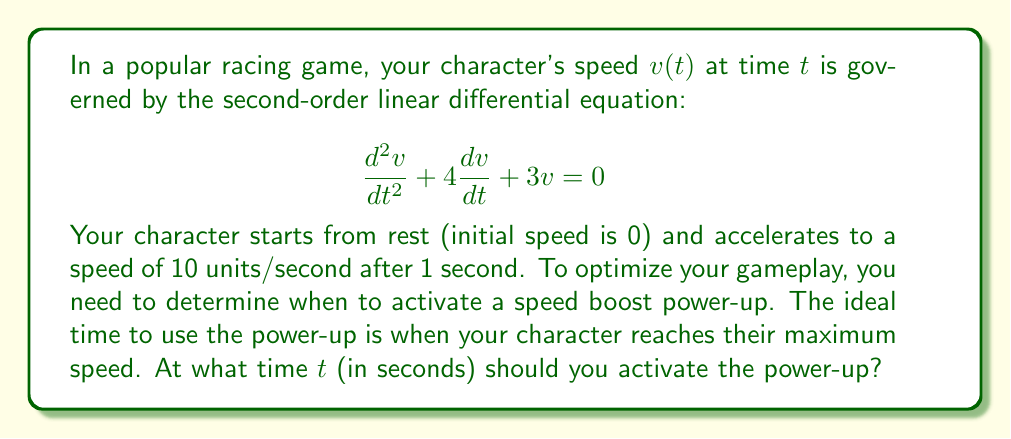Help me with this question. Let's approach this step-by-step:

1) First, we need to solve the differential equation. The characteristic equation is:
   
   $$r^2 + 4r + 3 = 0$$

2) Solving this quadratic equation:
   
   $$r = \frac{-4 \pm \sqrt{16 - 12}}{2} = \frac{-4 \pm 2}{2}$$
   
   $$r_1 = -1, r_2 = -3$$

3) Therefore, the general solution is:
   
   $$v(t) = c_1e^{-t} + c_2e^{-3t}$$

4) Now, we use the initial conditions:
   
   At $t=0$, $v(0) = 0$: $c_1 + c_2 = 0$
   At $t=1$, $v(1) = 10$: $c_1e^{-1} + c_2e^{-3} = 10$

5) From the first condition: $c_2 = -c_1$
   Substituting into the second condition:
   
   $$c_1e^{-1} - c_1e^{-3} = 10$$
   $$c_1(e^{-1} - e^{-3}) = 10$$
   $$c_1 = \frac{10}{e^{-1} - e^{-3}} \approx 15.77$$

6) So, $c_2 \approx -15.77$

7) Now we have the specific solution:
   
   $$v(t) = 15.77e^{-t} - 15.77e^{-3t}$$

8) To find the maximum speed, we differentiate and set to zero:
   
   $$\frac{dv}{dt} = -15.77e^{-t} + 47.31e^{-3t}$$
   
   $$-15.77e^{-t} + 47.31e^{-3t} = 0$$
   
   $$47.31e^{-3t} = 15.77e^{-t}$$
   
   $$3e^{2t} = 1$$
   
   $$e^{2t} = \frac{1}{3}$$
   
   $$2t = \ln(\frac{1}{3})$$
   
   $$t = \frac{1}{2}\ln(\frac{1}{3}) \approx 0.55$$

Therefore, the maximum speed occurs approximately 0.55 seconds after the start.
Answer: $t \approx 0.55$ seconds 